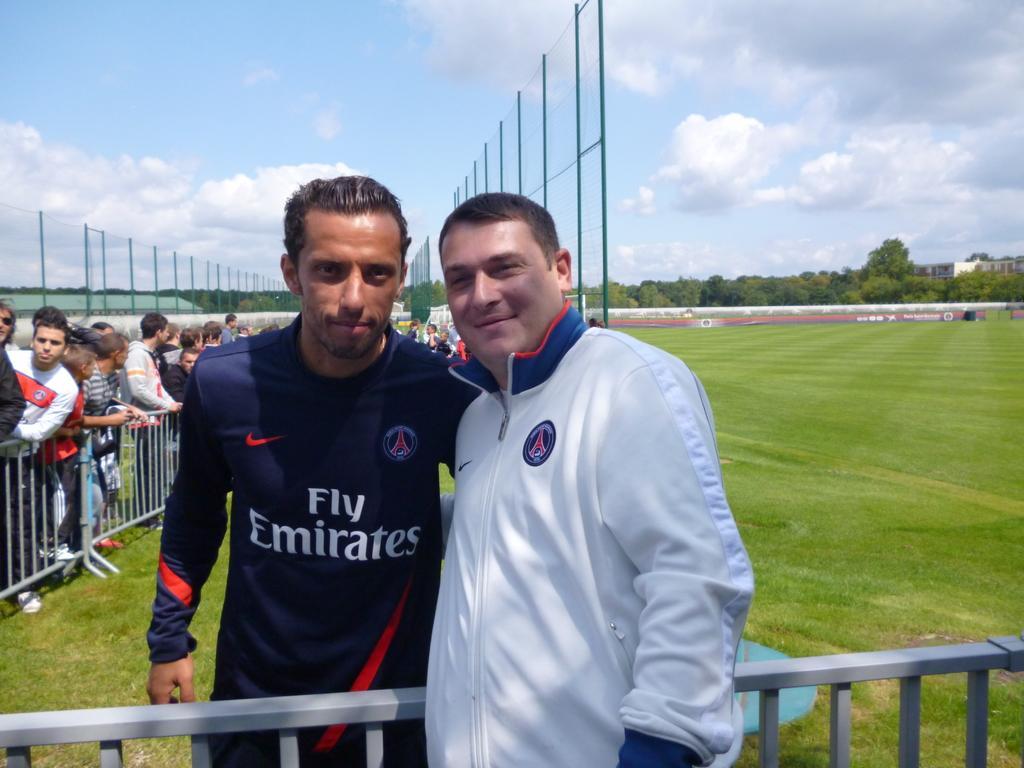In one or two sentences, can you explain what this image depicts? In this image we can see persons, railing and other objects. In the background of the image there are persons, railing, net, grass, trees, buildings and other objects. At the top of the image there is the sky. 